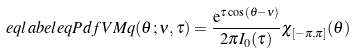Convert formula to latex. <formula><loc_0><loc_0><loc_500><loc_500>\ e q l a b e l { e q P d f V M } q ( \theta ; \nu , \tau ) = \frac { \mathrm e ^ { \tau \cos ( \theta - \nu ) } } { 2 \pi I _ { 0 } ( \tau ) } \chi _ { [ - \pi , \pi ] } ( \theta )</formula> 